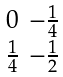Convert formula to latex. <formula><loc_0><loc_0><loc_500><loc_500>\begin{smallmatrix} 0 & - \frac { 1 } { 4 } \\ \frac { 1 } { 4 } & - \frac { 1 } { 2 } \end{smallmatrix}</formula> 